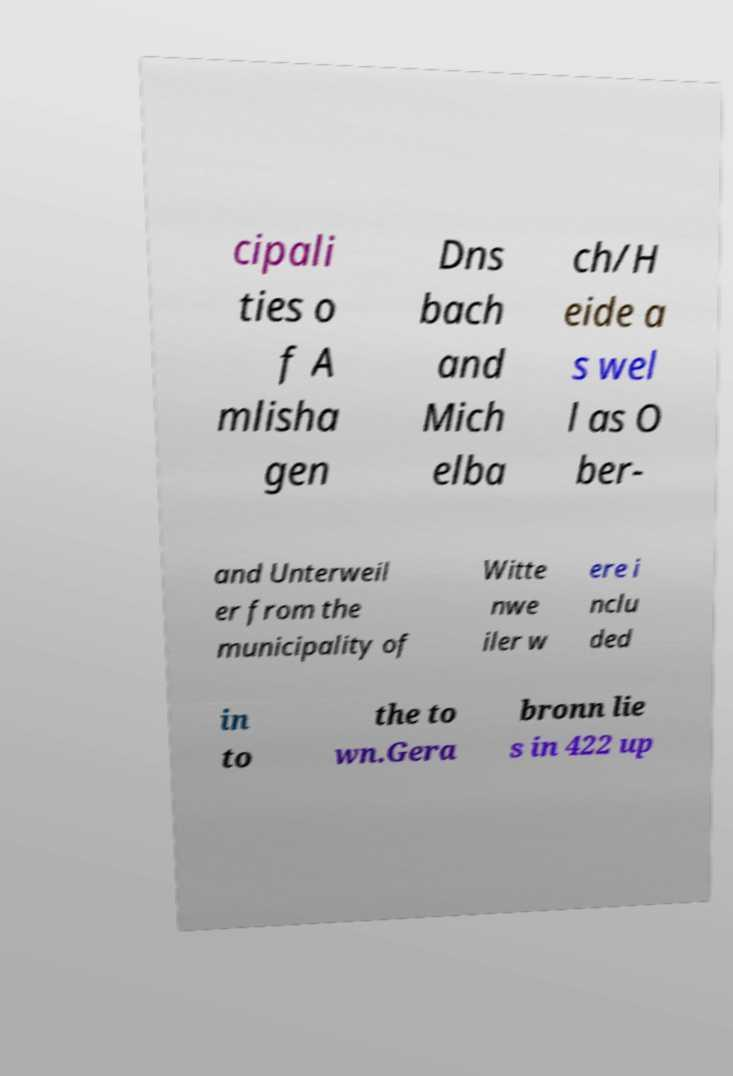Please read and relay the text visible in this image. What does it say? cipali ties o f A mlisha gen Dns bach and Mich elba ch/H eide a s wel l as O ber- and Unterweil er from the municipality of Witte nwe iler w ere i nclu ded in to the to wn.Gera bronn lie s in 422 up 